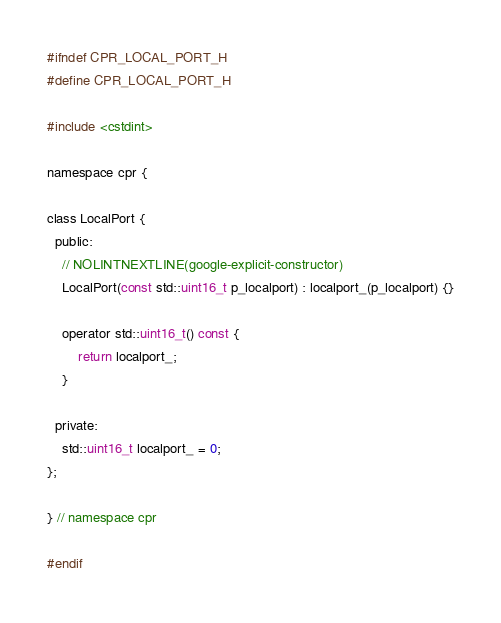<code> <loc_0><loc_0><loc_500><loc_500><_C_>#ifndef CPR_LOCAL_PORT_H
#define CPR_LOCAL_PORT_H

#include <cstdint>

namespace cpr {

class LocalPort {
  public:
    // NOLINTNEXTLINE(google-explicit-constructor)
    LocalPort(const std::uint16_t p_localport) : localport_(p_localport) {}

    operator std::uint16_t() const {
        return localport_;
    }

  private:
    std::uint16_t localport_ = 0;
};

} // namespace cpr

#endif</code> 